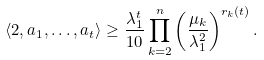Convert formula to latex. <formula><loc_0><loc_0><loc_500><loc_500>\langle 2 , a _ { 1 } , \dots , a _ { t } \rangle \geq \frac { \lambda _ { 1 } ^ { t } } { 1 0 } \prod _ { k = 2 } ^ { n } \left ( \frac { \mu _ { k } } { \lambda _ { 1 } ^ { 2 } } \right ) ^ { r _ { k } ( t ) } .</formula> 